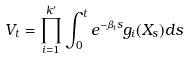Convert formula to latex. <formula><loc_0><loc_0><loc_500><loc_500>V _ { t } = \prod _ { i = 1 } ^ { k ^ { \prime } } \int _ { 0 } ^ { t } e ^ { - \beta _ { i } s } g _ { i } ( X _ { s } ) d s</formula> 